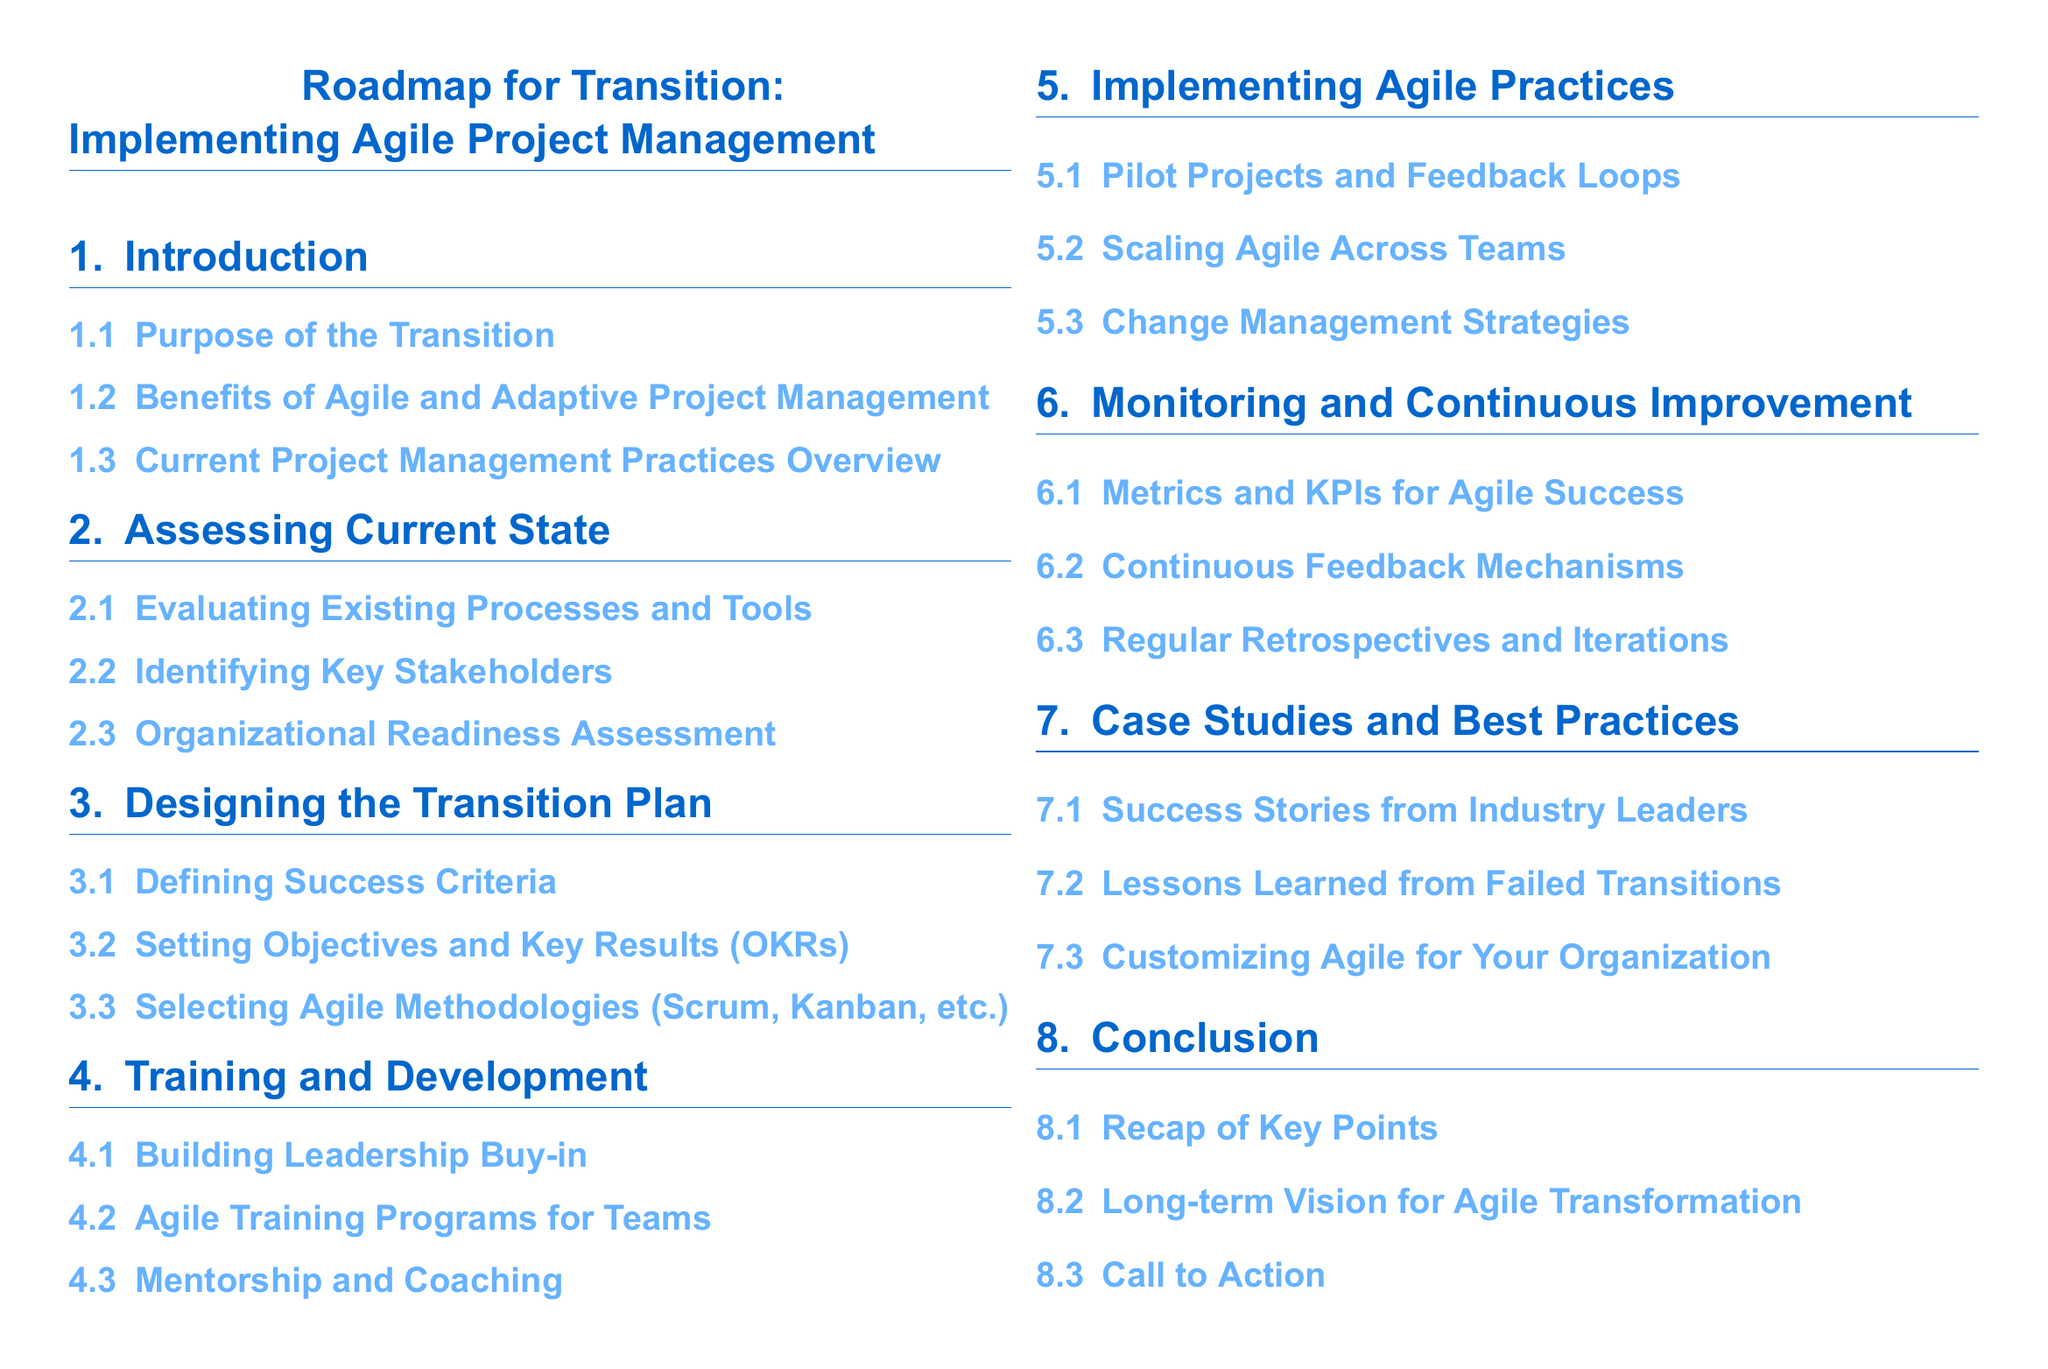What is the main focus of the document? The document focuses on how to implement Agile project management practices effectively.
Answer: Agile project management How many sections are in the roadmap? The roadmap consists of seven sections, each addressing a different aspect of the transition process.
Answer: Seven What is the first subsection under "Introduction"? The first subsection provides the purpose for transitioning to Agile practices.
Answer: Purpose of the Transition Which Agile methodologies are mentioned as options to select? The document specifically mentions Scrum and Kanban as Agile methodologies that can be selected.
Answer: Scrum, Kanban What type of assessment is included in the "Assessing Current State" section? The section includes an assessment to gauge the organization's readiness for Agile practices.
Answer: Organizational Readiness Assessment What is emphasized in the "Monitoring and Continuous Improvement" section? The importance of metrics and key performance indicators (KPIs) for measuring Agile success is emphasized.
Answer: Metrics and KPIs for Agile Success What is the last subsection of the document? The last subsection serves as a call to action regarding Agile transformation.
Answer: Call to Action 